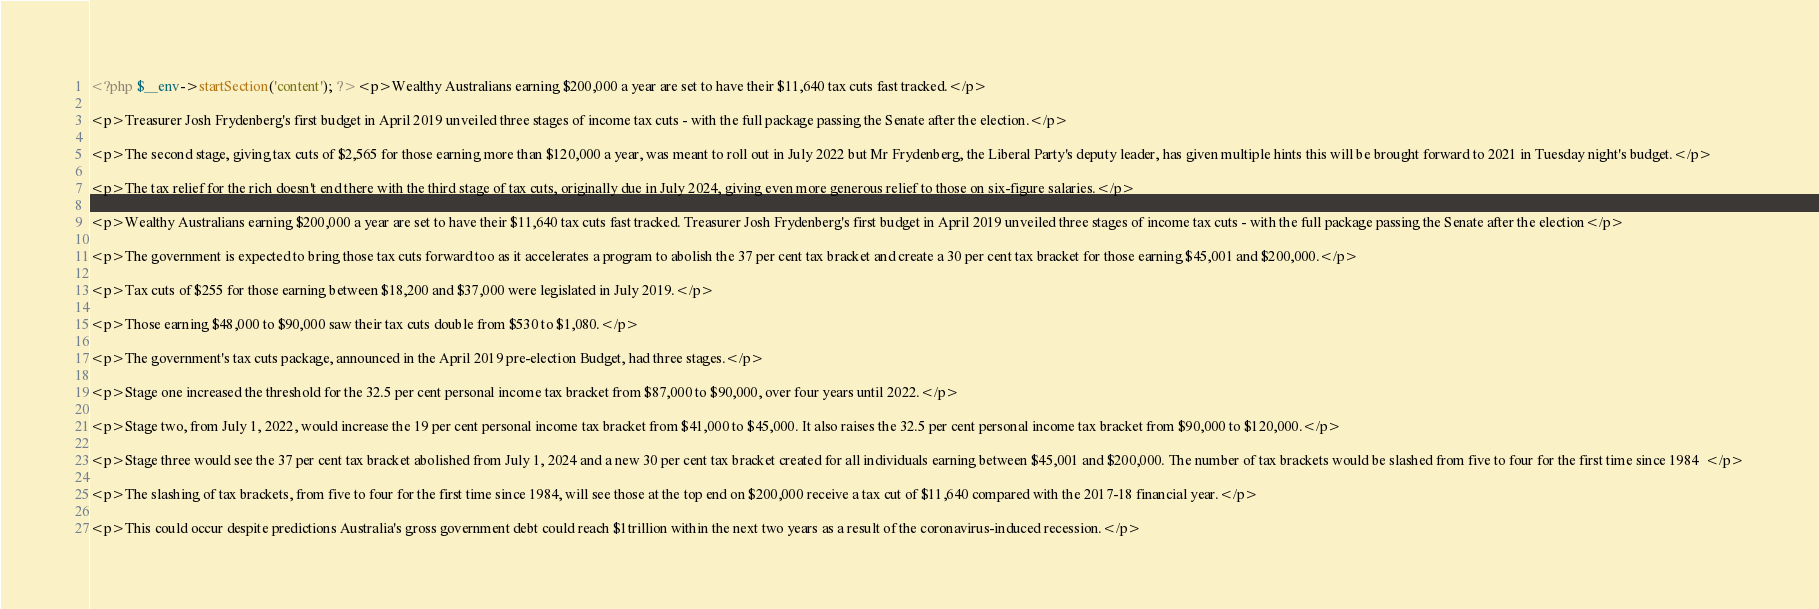<code> <loc_0><loc_0><loc_500><loc_500><_PHP_><?php $__env->startSection('content'); ?><p>Wealthy Australians earning $200,000 a year are set to have their $11,640 tax cuts fast tracked.</p>

<p>Treasurer Josh Frydenberg's first budget in April 2019 unveiled three stages of income tax cuts - with the full package passing the Senate after the election.</p>

<p>The second stage, giving tax cuts of $2,565 for those earning more than $120,000 a year, was meant to roll out in July 2022 but Mr Frydenberg, the Liberal Party's deputy leader, has given multiple hints this will be brought forward to 2021 in Tuesday night's budget.</p>

<p>The tax relief for the rich doesn't end there with the third stage of tax cuts, originally due in July 2024, giving even more generous relief to those on six-figure salaries.</p>

<p>Wealthy Australians earning $200,000 a year are set to have their $11,640 tax cuts fast tracked. Treasurer Josh Frydenberg's first budget in April 2019 unveiled three stages of income tax cuts - with the full package passing the Senate after the election</p>

<p>The government is expected to bring those tax cuts forward too as it accelerates a program to abolish the 37 per cent tax bracket and create a 30 per cent tax bracket for those earning $45,001 and $200,000.</p>

<p>Tax cuts of $255 for those earning between $18,200 and $37,000 were legislated in July 2019.</p>

<p>Those earning $48,000 to $90,000 saw their tax cuts double from $530 to $1,080.</p>

<p>The government's tax cuts package, announced in the April 2019 pre-election Budget, had three stages.</p>

<p>Stage one increased the threshold for the 32.5 per cent personal income tax bracket from $87,000 to $90,000, over four years until 2022.</p>

<p>Stage two, from July 1, 2022, would increase the 19 per cent personal income tax bracket from $41,000 to $45,000. It also raises the 32.5 per cent personal income tax bracket from $90,000 to $120,000.</p>

<p>Stage three would see the 37 per cent tax bracket abolished from July 1, 2024 and a new 30 per cent tax bracket created for all individuals earning between $45,001 and $200,000. The number of tax brackets would be slashed from five to four for the first time since 1984  </p>

<p>The slashing of tax brackets, from five to four for the first time since 1984, will see those at the top end on $200,000 receive a tax cut of $11,640 compared with the 2017-18 financial year.</p>

<p>This could occur despite predictions Australia's gross government debt could reach $1trillion within the next two years as a result of the coronavirus-induced recession.</p>
</code> 